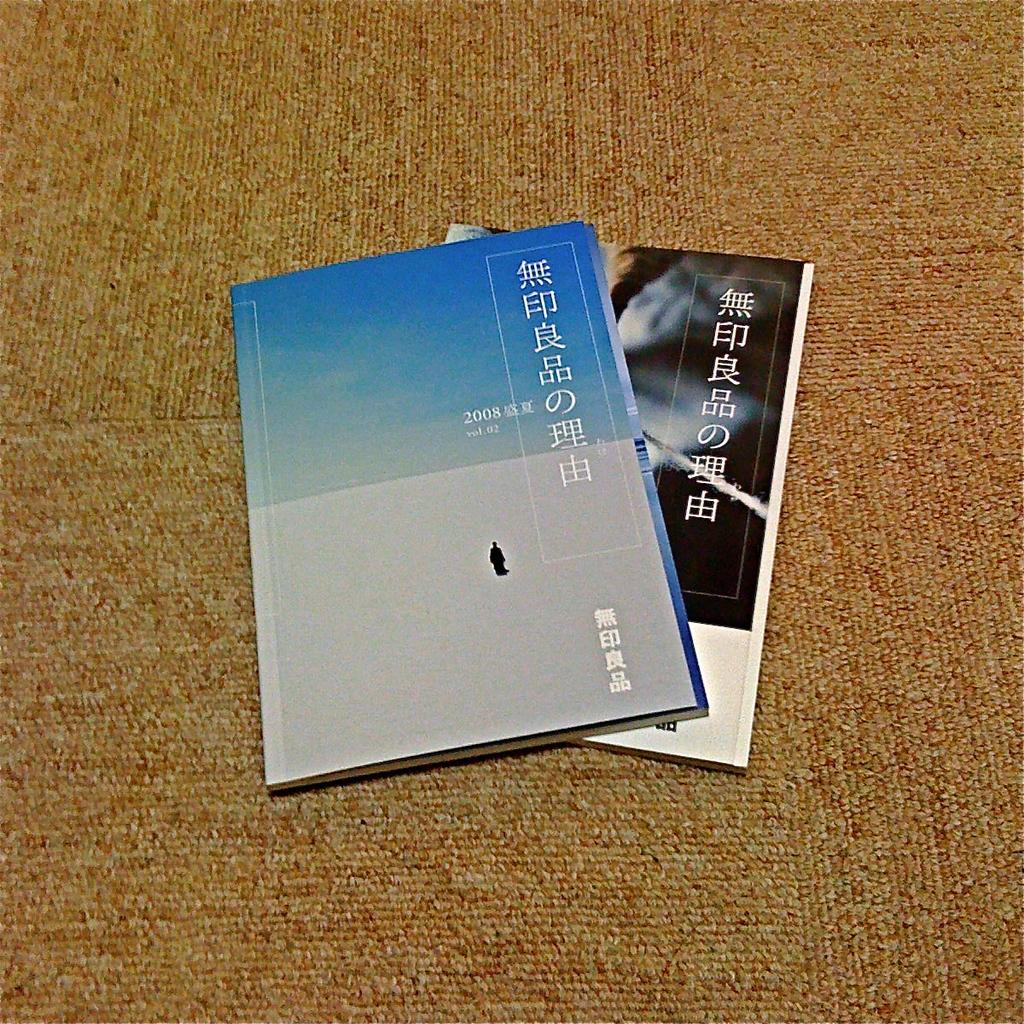What year is on the front?
Give a very brief answer. 2008. 